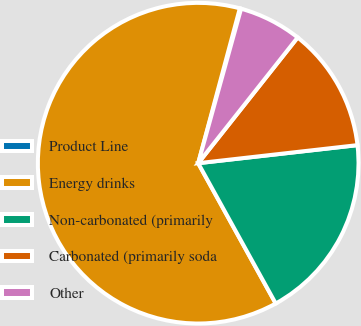Convert chart. <chart><loc_0><loc_0><loc_500><loc_500><pie_chart><fcel>Product Line<fcel>Energy drinks<fcel>Non-carbonated (primarily<fcel>Carbonated (primarily soda<fcel>Other<nl><fcel>0.13%<fcel>62.21%<fcel>18.76%<fcel>12.55%<fcel>6.34%<nl></chart> 